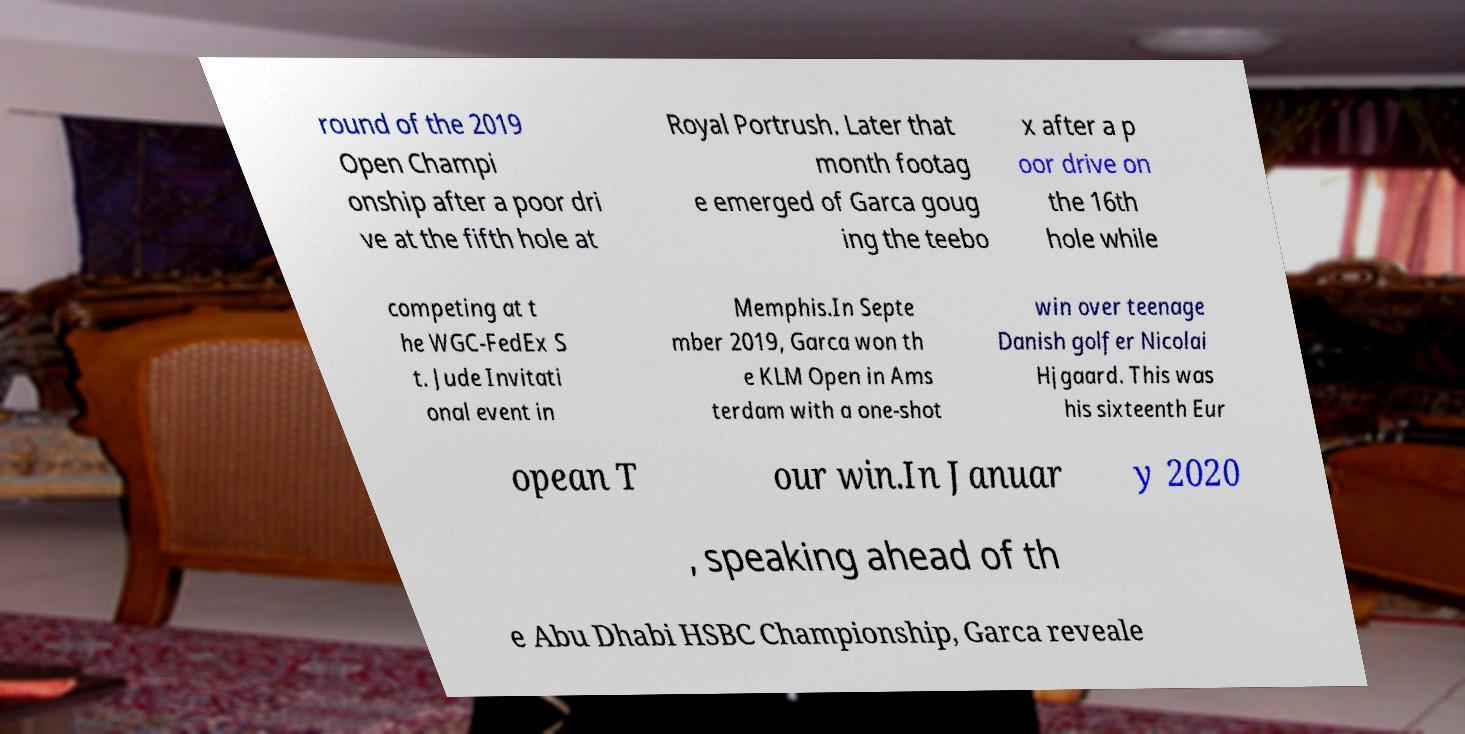Could you extract and type out the text from this image? round of the 2019 Open Champi onship after a poor dri ve at the fifth hole at Royal Portrush. Later that month footag e emerged of Garca goug ing the teebo x after a p oor drive on the 16th hole while competing at t he WGC-FedEx S t. Jude Invitati onal event in Memphis.In Septe mber 2019, Garca won th e KLM Open in Ams terdam with a one-shot win over teenage Danish golfer Nicolai Hjgaard. This was his sixteenth Eur opean T our win.In Januar y 2020 , speaking ahead of th e Abu Dhabi HSBC Championship, Garca reveale 